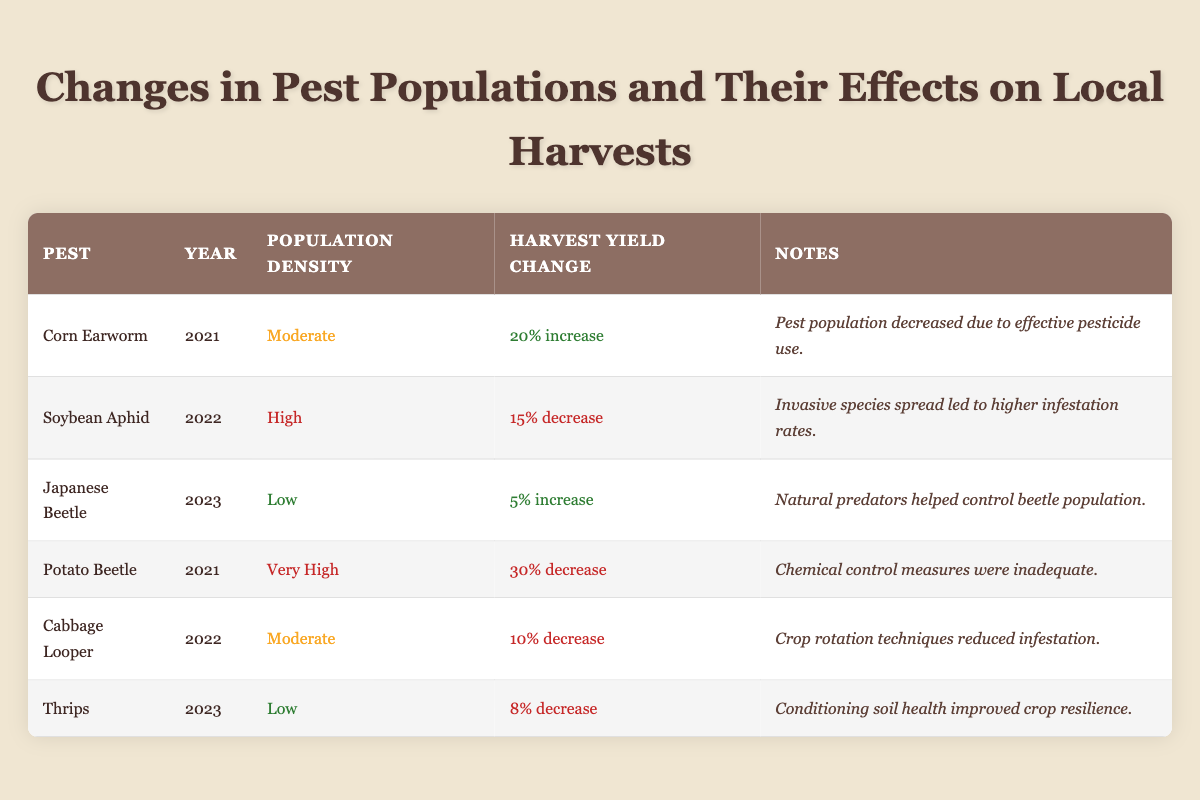What was the harvest yield improvement for Corn Earworm in 2021? The data shows the row for Corn Earworm lists a "20% increase" in harvest yield improvement for the year 2021.
Answer: 20% increase Which pest had the highest population density in 2022? According to the table, the Soybean Aphid is marked with "High" population density in the year 2022, which is the highest density reported for that year.
Answer: Soybean Aphid How many pests are listed with a 5% or greater increase in harvest yield? The table shows two pests with an increase in harvest yield: Corn Earworm with a 20% increase and Japanese Beetle with a 5% increase, totaling two pests that meet this criterion.
Answer: 2 Is it true that the Potato Beetle caused a decrease in harvest yield in 2021? Yes, the table indicates that the Potato Beetle had a "30% decrease" in harvest yield in 2021, confirming that it did negatively impact the harvest for that year.
Answer: Yes What is the average harvest yield change from all the pests listed for 2023? For 2023, there are two pests: Japanese Beetle with a 5% increase and Thrips with an 8% decrease. To calculate the average, convert the percentages: (5 - 8) / 2 = -1.5, representing a 1.5% decrease on average across the two pests.
Answer: 1.5% decrease 